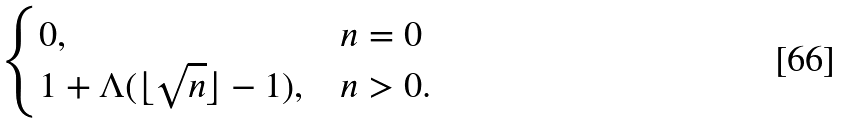<formula> <loc_0><loc_0><loc_500><loc_500>\begin{cases} 0 , & n = 0 \\ 1 + \Lambda ( \lfloor \sqrt { n } \rfloor - 1 ) , & n > 0 . \end{cases}</formula> 